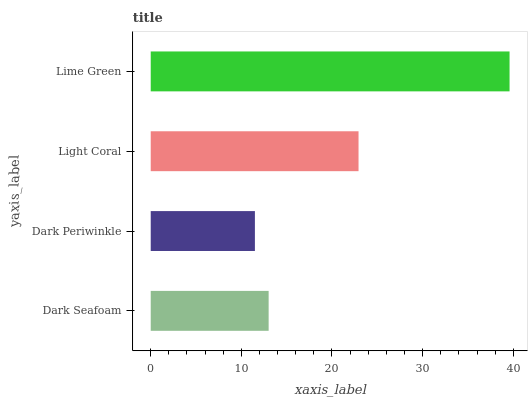Is Dark Periwinkle the minimum?
Answer yes or no. Yes. Is Lime Green the maximum?
Answer yes or no. Yes. Is Light Coral the minimum?
Answer yes or no. No. Is Light Coral the maximum?
Answer yes or no. No. Is Light Coral greater than Dark Periwinkle?
Answer yes or no. Yes. Is Dark Periwinkle less than Light Coral?
Answer yes or no. Yes. Is Dark Periwinkle greater than Light Coral?
Answer yes or no. No. Is Light Coral less than Dark Periwinkle?
Answer yes or no. No. Is Light Coral the high median?
Answer yes or no. Yes. Is Dark Seafoam the low median?
Answer yes or no. Yes. Is Dark Seafoam the high median?
Answer yes or no. No. Is Lime Green the low median?
Answer yes or no. No. 